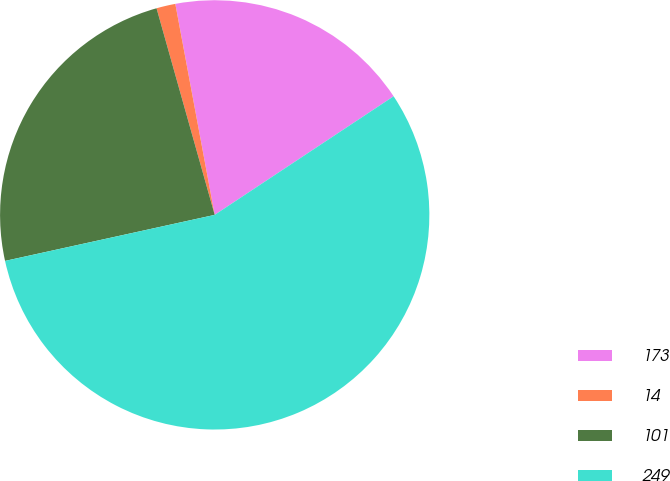Convert chart. <chart><loc_0><loc_0><loc_500><loc_500><pie_chart><fcel>173<fcel>14<fcel>101<fcel>249<nl><fcel>18.62%<fcel>1.43%<fcel>24.07%<fcel>55.87%<nl></chart> 